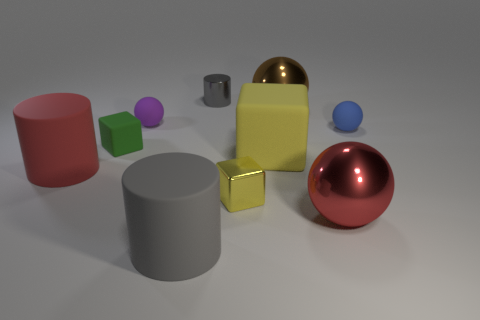Subtract all red metallic balls. How many balls are left? 3 Subtract all blue cylinders. How many yellow cubes are left? 2 Subtract 1 blocks. How many blocks are left? 2 Subtract all purple balls. How many balls are left? 3 Subtract all blocks. How many objects are left? 7 Subtract all yellow cylinders. Subtract all green spheres. How many cylinders are left? 3 Add 8 green rubber spheres. How many green rubber spheres exist? 8 Subtract 1 green blocks. How many objects are left? 9 Subtract all tiny spheres. Subtract all large brown metallic objects. How many objects are left? 7 Add 7 small metallic cubes. How many small metallic cubes are left? 8 